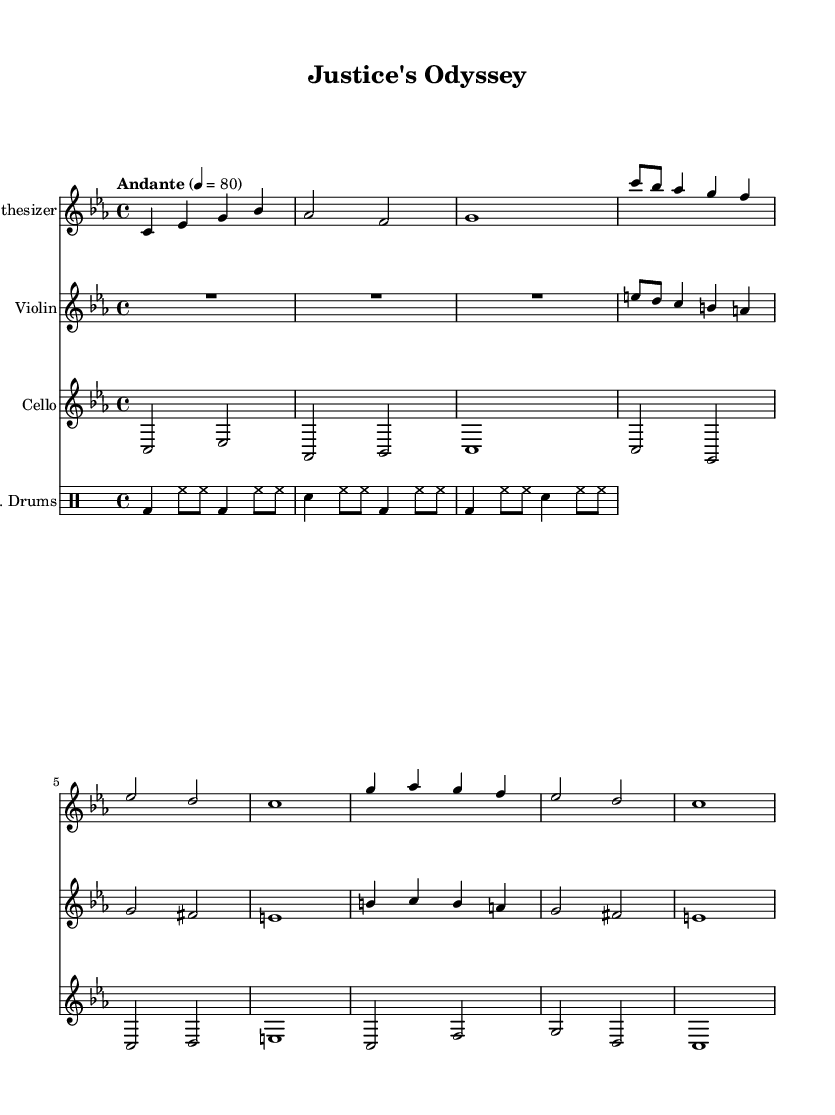What is the key signature of this music? The key signature is C minor, which has three flats (B flat, E flat, and A flat).
Answer: C minor What is the time signature of this music? The time signature is 4/4, which indicates four beats per measure and a quarter note receives one beat.
Answer: 4/4 What is the tempo marking indicated in this score? The score indicates a tempo marking of Andante, which typically means a moderate pace, around 76 to 108 beats per minute.
Answer: Andante How many instruments are featured in this piece? The score includes a synthesizer, violin, cello, and electronic drums, totaling four instruments.
Answer: Four Which instrument has the highest pitch range in this composition? The violin, notated in the treble clef, has the highest pitch range among the instruments in this score.
Answer: Violin Describe the role of the synthesizer in this piece. The synthesizer mainly provides harmonic support and texture, creating a foundation for the melodic lines of the violin and cello.
Answer: Harmonic support What is the overall mood conveyed by this electronic-classical fusion? The combination of electronic elements with classical instrumentation evokes a reflective and contemplative journey, representing the complexities of the legal system.
Answer: Reflective 